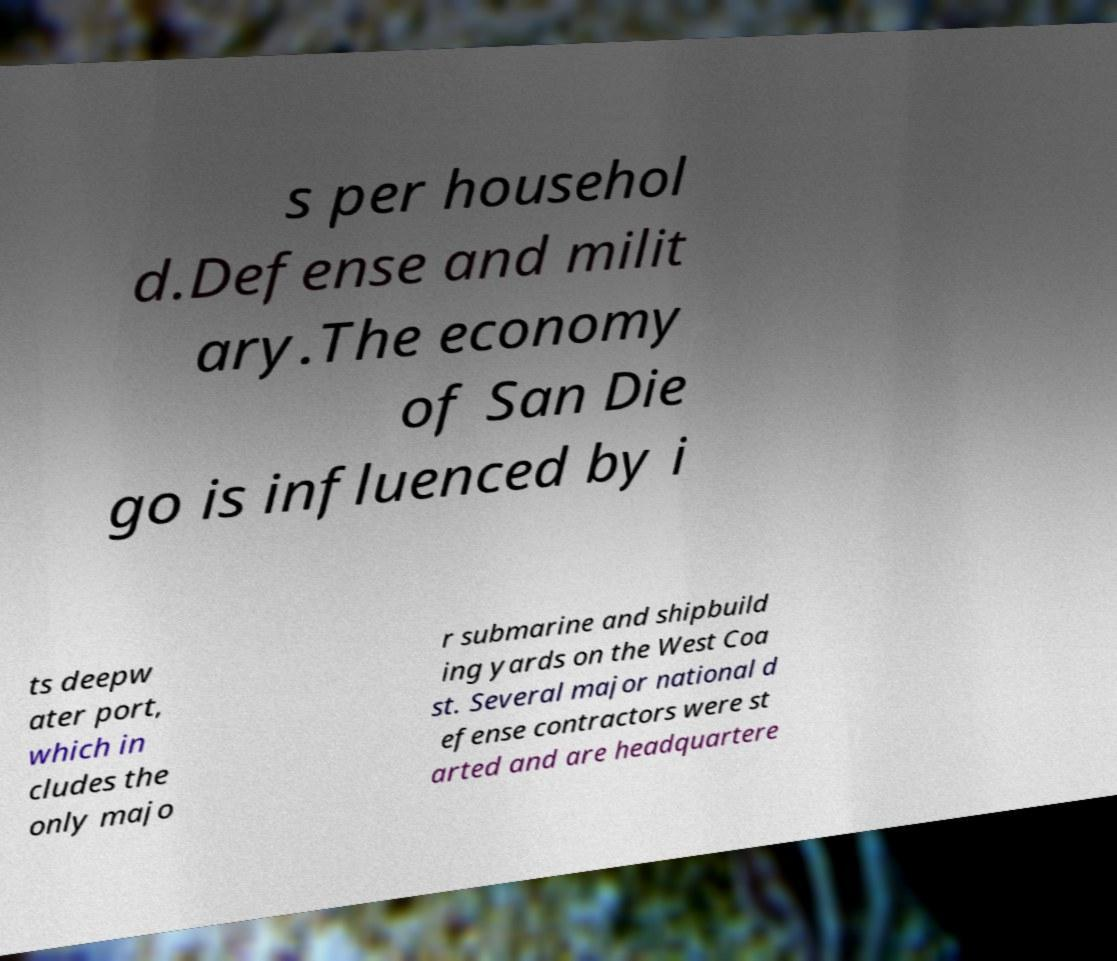There's text embedded in this image that I need extracted. Can you transcribe it verbatim? s per househol d.Defense and milit ary.The economy of San Die go is influenced by i ts deepw ater port, which in cludes the only majo r submarine and shipbuild ing yards on the West Coa st. Several major national d efense contractors were st arted and are headquartere 